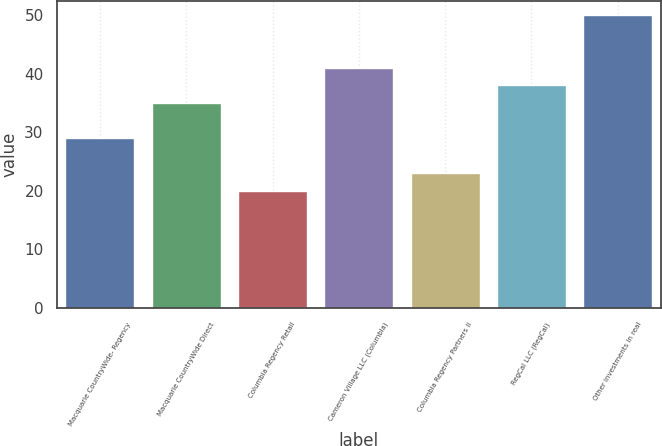<chart> <loc_0><loc_0><loc_500><loc_500><bar_chart><fcel>Macquarie CountryWide- Regency<fcel>Macquarie CountryWide Direct<fcel>Columbia Regency Retail<fcel>Cameron Village LLC (Columbia)<fcel>Columbia Regency Partners II<fcel>RegCal LLC (RegCal)<fcel>Other investments in real<nl><fcel>29<fcel>35<fcel>20<fcel>41<fcel>23<fcel>38<fcel>50<nl></chart> 